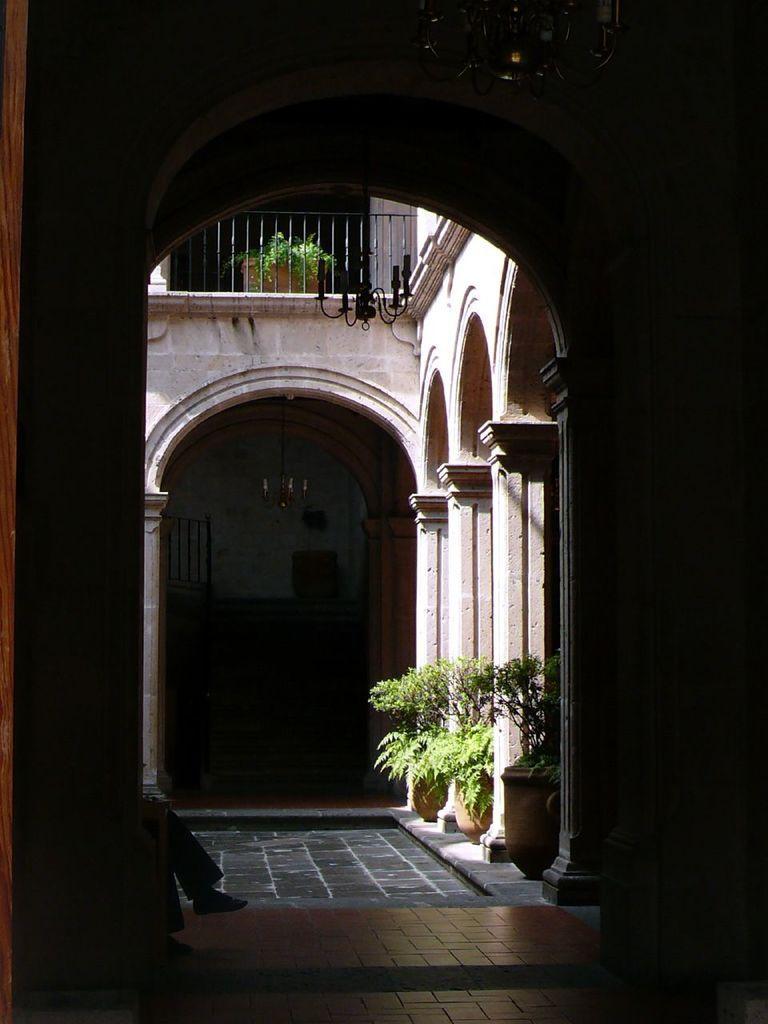In one or two sentences, can you explain what this image depicts? In this picture we can see an inside view of a building, here we can see a person's legs and houseplants on the floor. 